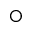Convert formula to latex. <formula><loc_0><loc_0><loc_500><loc_500>\bigcirc</formula> 